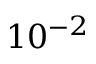<formula> <loc_0><loc_0><loc_500><loc_500>1 0 ^ { - 2 }</formula> 